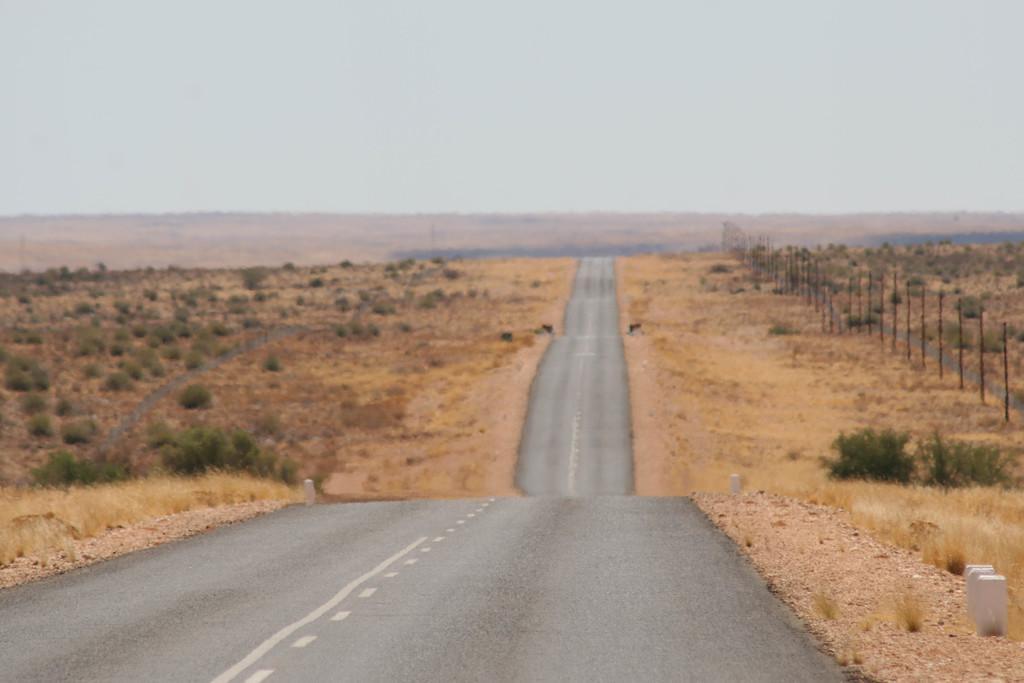How would you summarize this image in a sentence or two? In this image we can see a road. To the both sides of the road land and plants are there. Right side of the image fencing is there. At the top of the image sky is present. 